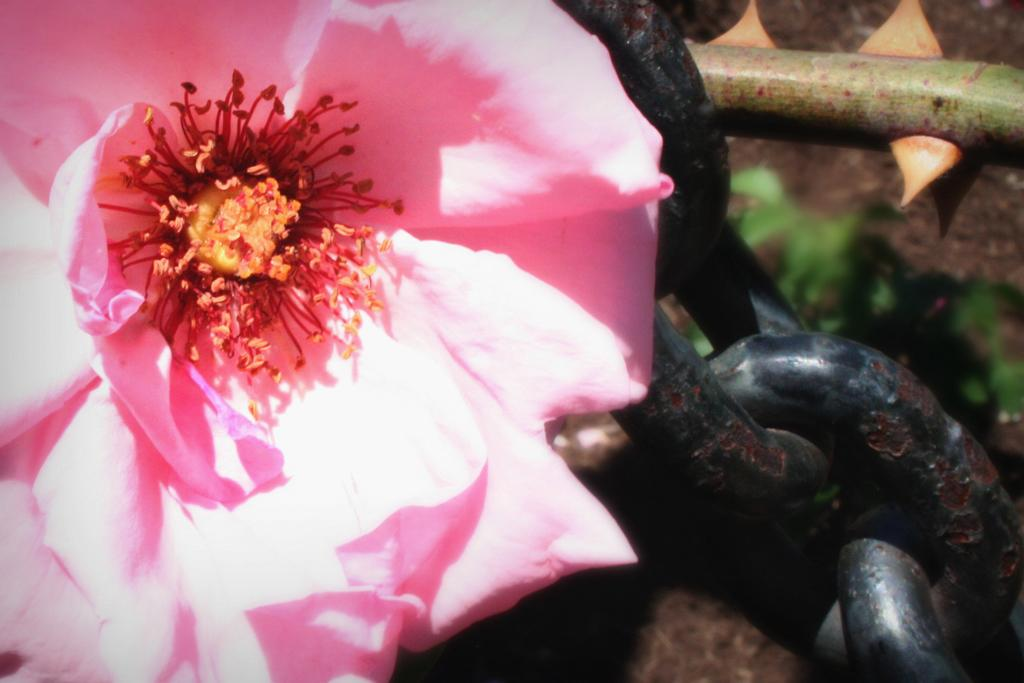What type of plant can be seen in the image? There is a flower in the image. What other object is present in the image besides the flower? There are links of a chain in the image. How does the flower give a haircut in the image? The flower does not give a haircut in the image; it is a static object and not capable of performing such an action. 